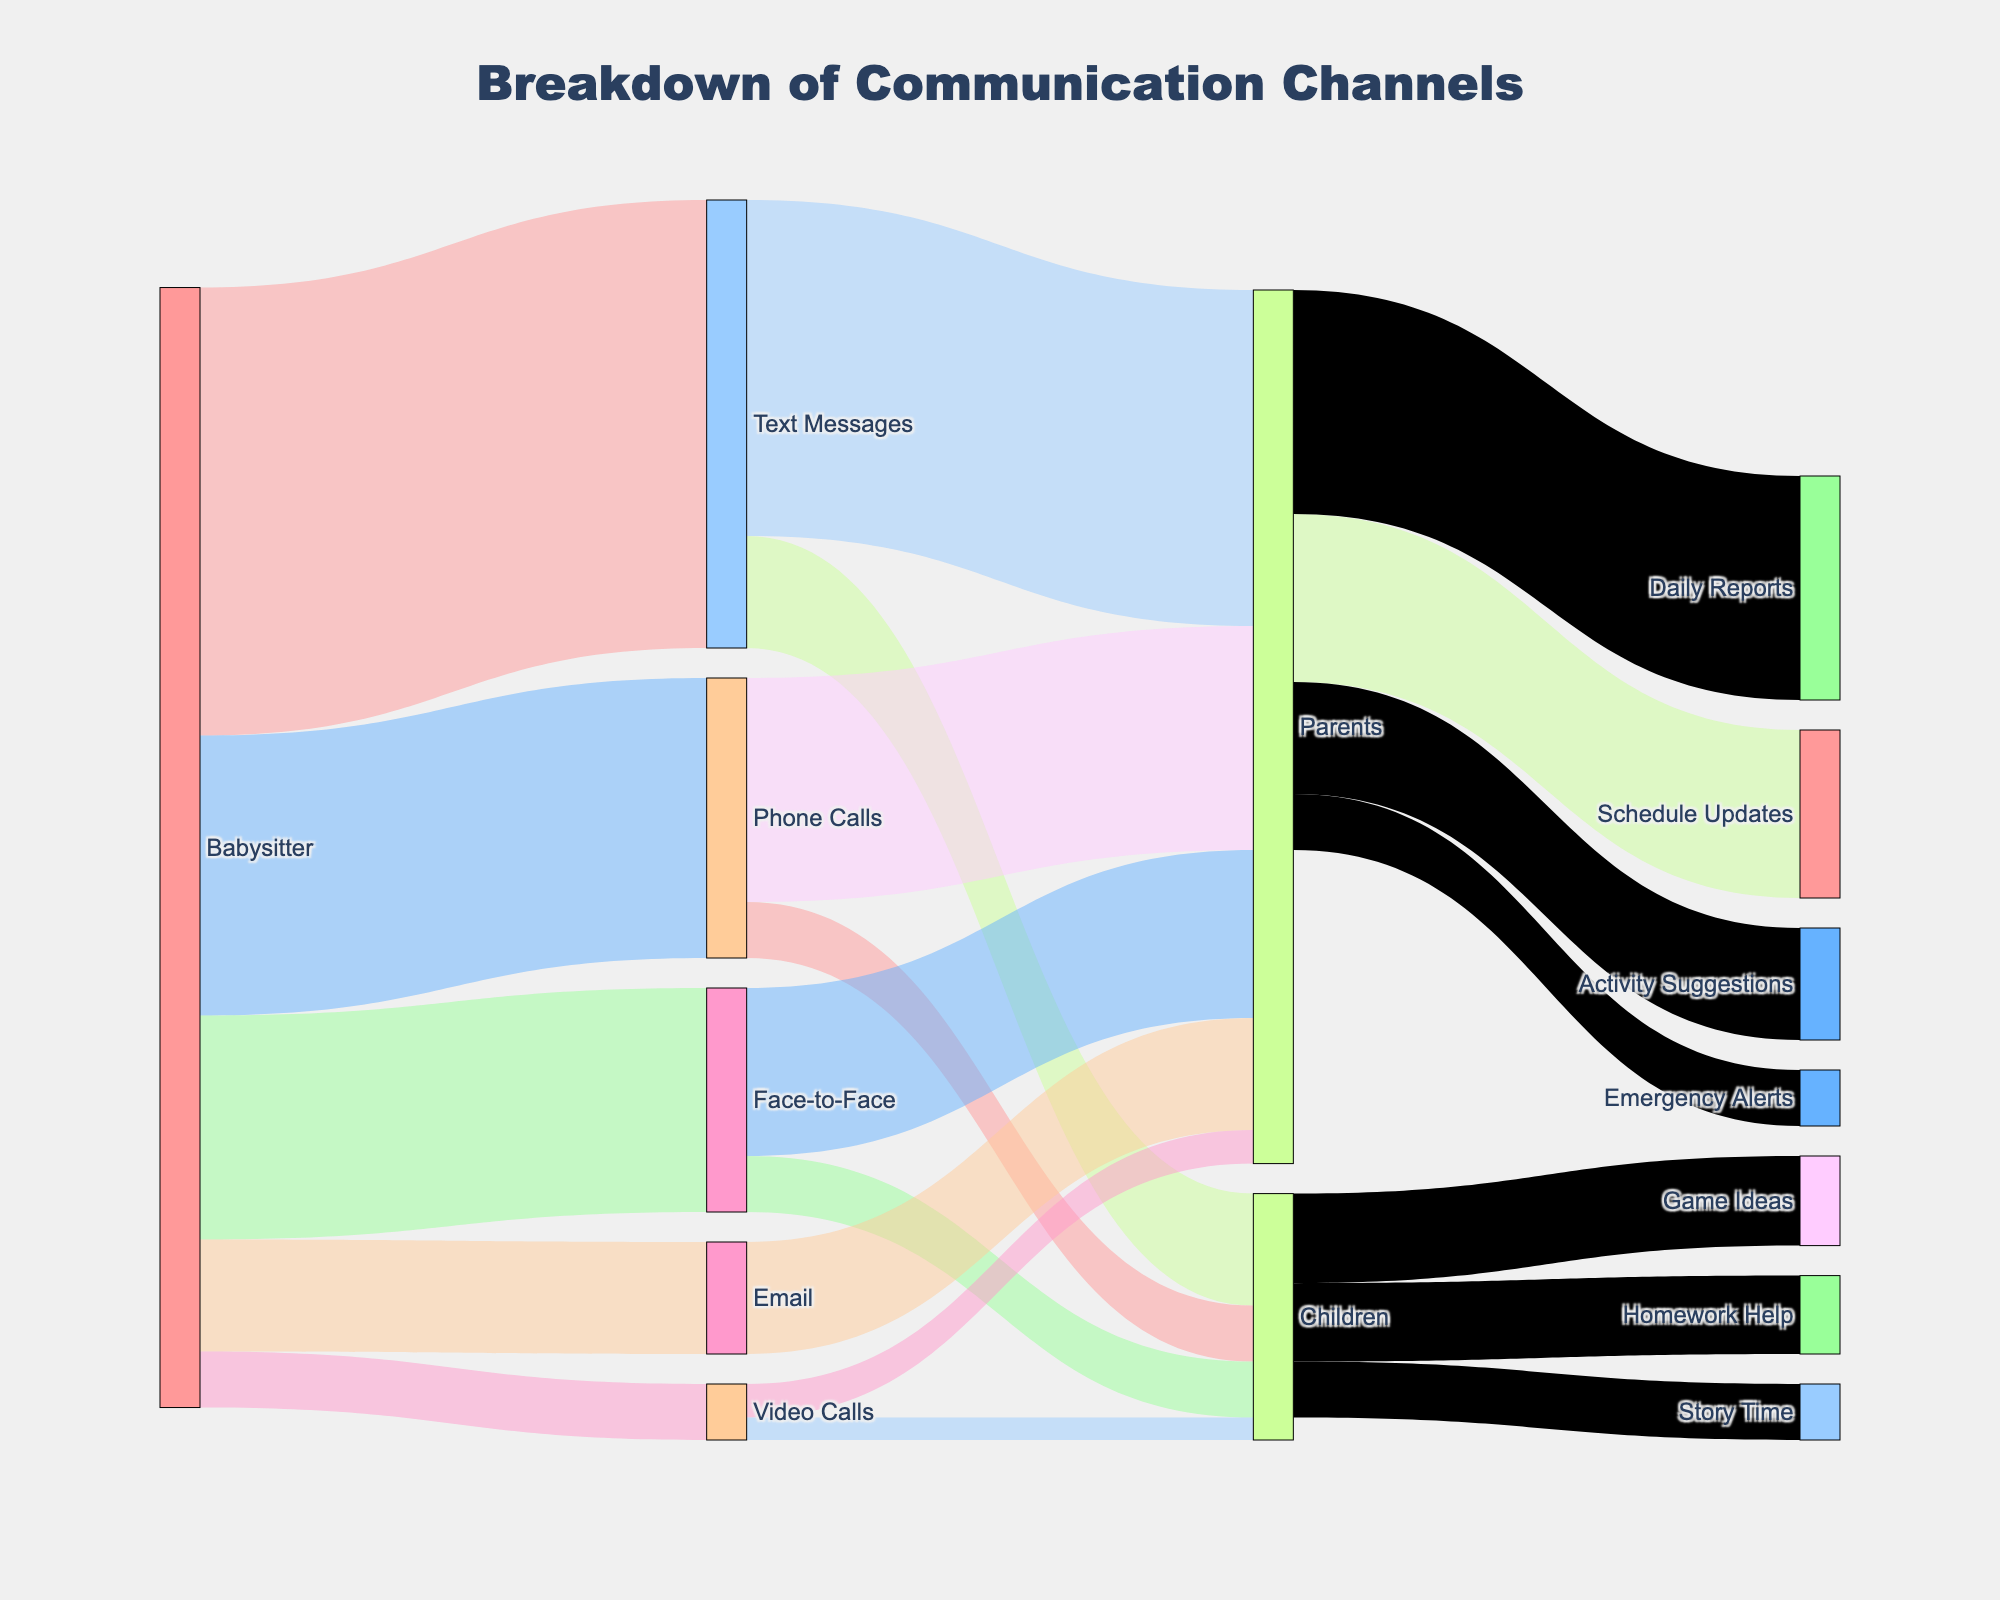What's the color of the node "Phone Calls"? The node "Phone Calls" uses the second color in the color palette, which is blue. This can be identified by looking at second position in the color sequence applied to nodes in the diagram.
Answer: Blue How many different communication channels does the babysitter use? By looking at the diagram, we see the babysitter uses "Text Messages," "Phone Calls," "Face-to-Face," "Email," and "Video Calls," which adds up to 5 channels.
Answer: 5 Which group does the babysitter send the highest number of text messages to? The "Text Messages" node splits into two targets, "Parents" and "Children." The value of messages to "Parents" is 30, which is higher than the value to "Children" which is 10.
Answer: Parents What communication method has the highest engagement with children? Examining the values leading to "Children," "Text Messages" has the highest value of 10 compared to 5 from "Phone Calls," 5 from "Face-to-Face," and 2 from "Video Calls."
Answer: Text Messages What is the total number of engagements the babysitter has with parents across all channels? Sum the values directed towards "Parents" from each communication channel: 30 (Text Messages) + 20 (Phone Calls) + 15 (Face-to-Face) + 10 (Email) + 3 (Video Calls).
Answer: 78 How do the babysitter's communication methods differ in their use for parents vs. children? Compare the summed values: "Text Messages" (30 for Parents vs. 10 for Children), "Phone Calls" (20 for Parents vs. 5 for Children), "Face-to-Face" (15 for Parents vs. 5 for Children), "Email" (10 for Parents vs. none), "Video Calls" (3 for Parents vs. 2 for Children). Parents are engaged more across almost all methods, especially in text and phone calls where the disparity is largest.
Answer: Parents are engaged more What type of information is most frequently communicated to parents? Break down "Parents" node to see the values for "Schedule Updates" (15), "Daily Reports" (20), "Emergency Alerts" (5), and "Activity Suggestions" (10). "Daily Reports" has the highest value at 20.
Answer: Daily Reports How many connections are represented in total in the diagram? Count the total number of unique flows or links between nodes: each row in the data represents one. There are 17 links in total.
Answer: 17 What's the total value of communications related to "Children"? Sum values directed to "Children" from different communication channels and the split into their subcategories: 10 (Text Messages) + 5 (Phone Calls) + 5 (Face-to-Face) + 2 (Video Calls). No emails are directed to children.
Answer: 22 